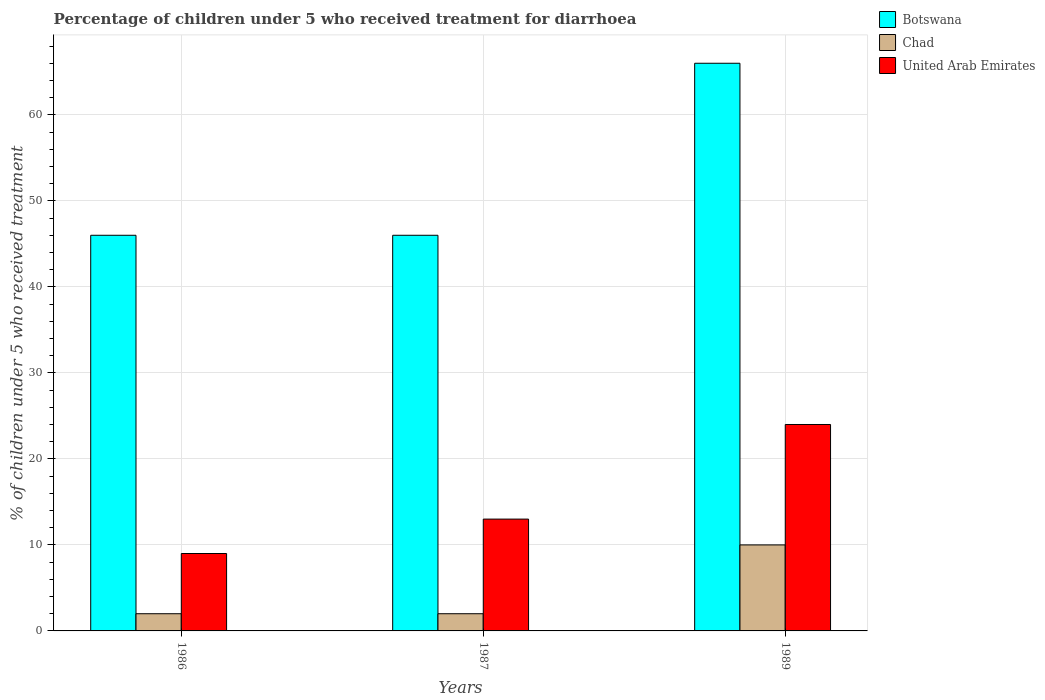Are the number of bars on each tick of the X-axis equal?
Offer a very short reply. Yes. In how many cases, is the number of bars for a given year not equal to the number of legend labels?
Your response must be concise. 0. What is the percentage of children who received treatment for diarrhoea  in Botswana in 1987?
Provide a short and direct response. 46. In which year was the percentage of children who received treatment for diarrhoea  in Botswana maximum?
Offer a very short reply. 1989. In which year was the percentage of children who received treatment for diarrhoea  in Botswana minimum?
Ensure brevity in your answer.  1986. What is the total percentage of children who received treatment for diarrhoea  in United Arab Emirates in the graph?
Your answer should be very brief. 46. What is the average percentage of children who received treatment for diarrhoea  in Botswana per year?
Make the answer very short. 52.67. In how many years, is the percentage of children who received treatment for diarrhoea  in Chad greater than 24 %?
Your response must be concise. 0. What is the ratio of the percentage of children who received treatment for diarrhoea  in Chad in 1986 to that in 1987?
Your answer should be very brief. 1. Is the percentage of children who received treatment for diarrhoea  in Chad in 1986 less than that in 1987?
Keep it short and to the point. No. What is the difference between the highest and the lowest percentage of children who received treatment for diarrhoea  in United Arab Emirates?
Make the answer very short. 15. In how many years, is the percentage of children who received treatment for diarrhoea  in Botswana greater than the average percentage of children who received treatment for diarrhoea  in Botswana taken over all years?
Provide a succinct answer. 1. What does the 2nd bar from the left in 1989 represents?
Make the answer very short. Chad. What does the 1st bar from the right in 1989 represents?
Provide a short and direct response. United Arab Emirates. Is it the case that in every year, the sum of the percentage of children who received treatment for diarrhoea  in United Arab Emirates and percentage of children who received treatment for diarrhoea  in Chad is greater than the percentage of children who received treatment for diarrhoea  in Botswana?
Your response must be concise. No. Are all the bars in the graph horizontal?
Provide a short and direct response. No. How many years are there in the graph?
Your response must be concise. 3. What is the difference between two consecutive major ticks on the Y-axis?
Offer a terse response. 10. Are the values on the major ticks of Y-axis written in scientific E-notation?
Your response must be concise. No. Does the graph contain grids?
Provide a short and direct response. Yes. How many legend labels are there?
Give a very brief answer. 3. What is the title of the graph?
Ensure brevity in your answer.  Percentage of children under 5 who received treatment for diarrhoea. What is the label or title of the X-axis?
Provide a succinct answer. Years. What is the label or title of the Y-axis?
Provide a short and direct response. % of children under 5 who received treatment. What is the % of children under 5 who received treatment in Botswana in 1986?
Your answer should be compact. 46. What is the % of children under 5 who received treatment in United Arab Emirates in 1986?
Keep it short and to the point. 9. What is the % of children under 5 who received treatment of Chad in 1987?
Ensure brevity in your answer.  2. What is the % of children under 5 who received treatment in Chad in 1989?
Offer a terse response. 10. Across all years, what is the maximum % of children under 5 who received treatment in Chad?
Give a very brief answer. 10. Across all years, what is the minimum % of children under 5 who received treatment in United Arab Emirates?
Your response must be concise. 9. What is the total % of children under 5 who received treatment in Botswana in the graph?
Provide a short and direct response. 158. What is the total % of children under 5 who received treatment in Chad in the graph?
Keep it short and to the point. 14. What is the difference between the % of children under 5 who received treatment in Botswana in 1986 and that in 1987?
Your response must be concise. 0. What is the difference between the % of children under 5 who received treatment of United Arab Emirates in 1987 and that in 1989?
Ensure brevity in your answer.  -11. What is the difference between the % of children under 5 who received treatment of Botswana in 1986 and the % of children under 5 who received treatment of Chad in 1987?
Offer a very short reply. 44. What is the difference between the % of children under 5 who received treatment of Botswana in 1986 and the % of children under 5 who received treatment of United Arab Emirates in 1987?
Keep it short and to the point. 33. What is the difference between the % of children under 5 who received treatment of Botswana in 1986 and the % of children under 5 who received treatment of United Arab Emirates in 1989?
Provide a succinct answer. 22. What is the difference between the % of children under 5 who received treatment of Chad in 1986 and the % of children under 5 who received treatment of United Arab Emirates in 1989?
Keep it short and to the point. -22. What is the difference between the % of children under 5 who received treatment of Botswana in 1987 and the % of children under 5 who received treatment of United Arab Emirates in 1989?
Make the answer very short. 22. What is the average % of children under 5 who received treatment of Botswana per year?
Provide a short and direct response. 52.67. What is the average % of children under 5 who received treatment of Chad per year?
Provide a succinct answer. 4.67. What is the average % of children under 5 who received treatment in United Arab Emirates per year?
Your response must be concise. 15.33. In the year 1986, what is the difference between the % of children under 5 who received treatment in Botswana and % of children under 5 who received treatment in Chad?
Give a very brief answer. 44. In the year 1987, what is the difference between the % of children under 5 who received treatment of Chad and % of children under 5 who received treatment of United Arab Emirates?
Your answer should be very brief. -11. In the year 1989, what is the difference between the % of children under 5 who received treatment of Botswana and % of children under 5 who received treatment of United Arab Emirates?
Ensure brevity in your answer.  42. In the year 1989, what is the difference between the % of children under 5 who received treatment of Chad and % of children under 5 who received treatment of United Arab Emirates?
Provide a succinct answer. -14. What is the ratio of the % of children under 5 who received treatment of Botswana in 1986 to that in 1987?
Provide a succinct answer. 1. What is the ratio of the % of children under 5 who received treatment in Chad in 1986 to that in 1987?
Your answer should be very brief. 1. What is the ratio of the % of children under 5 who received treatment in United Arab Emirates in 1986 to that in 1987?
Give a very brief answer. 0.69. What is the ratio of the % of children under 5 who received treatment of Botswana in 1986 to that in 1989?
Provide a short and direct response. 0.7. What is the ratio of the % of children under 5 who received treatment of Chad in 1986 to that in 1989?
Give a very brief answer. 0.2. What is the ratio of the % of children under 5 who received treatment of Botswana in 1987 to that in 1989?
Provide a succinct answer. 0.7. What is the ratio of the % of children under 5 who received treatment of United Arab Emirates in 1987 to that in 1989?
Provide a short and direct response. 0.54. What is the difference between the highest and the second highest % of children under 5 who received treatment in United Arab Emirates?
Your response must be concise. 11. What is the difference between the highest and the lowest % of children under 5 who received treatment of United Arab Emirates?
Offer a terse response. 15. 